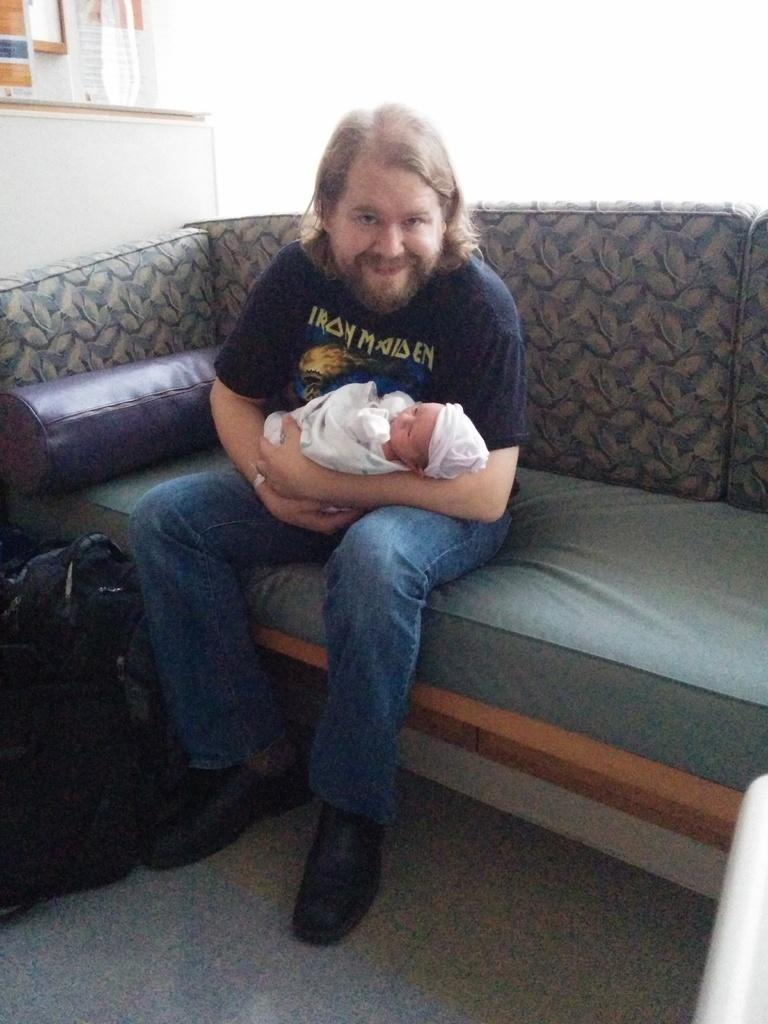What is the man in the image doing? The man is sitting on a sofa in the image. What is the man holding in the image? The man is holding a baby in the image. What expression does the man have on his face? The man has a smile on his face in the image. What else can be seen in the image besides the man and the baby? There is a bag visible in the image. What type of brush is being used to clean the sleet off the seat in the image? There is no brush, sleet, or seat present in the image. 